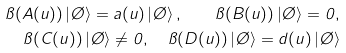Convert formula to latex. <formula><loc_0><loc_0><loc_500><loc_500>\pi ( A ( u ) ) \left | \chi \right > = a ( u ) \left | \chi \right > , \quad \pi ( B ( u ) ) \left | \chi \right > = 0 , \\ \pi ( C ( u ) ) \left | \chi \right > \neq 0 , \quad \pi ( D ( u ) ) \left | \chi \right > = d ( u ) \left | \chi \right ></formula> 